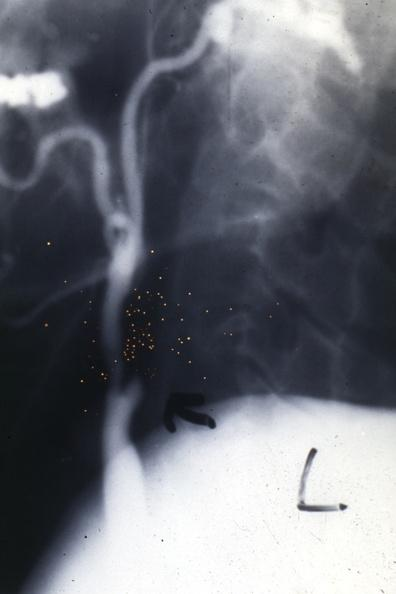what does this image show?
Answer the question using a single word or phrase. Carotid sclerosing panarteritis 